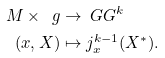Convert formula to latex. <formula><loc_0><loc_0><loc_500><loc_500>M \times \ g & \rightarrow \ G G ^ { k } \\ ( x , X ) & \mapsto j ^ { k - 1 } _ { x } ( X ^ { * } ) .</formula> 